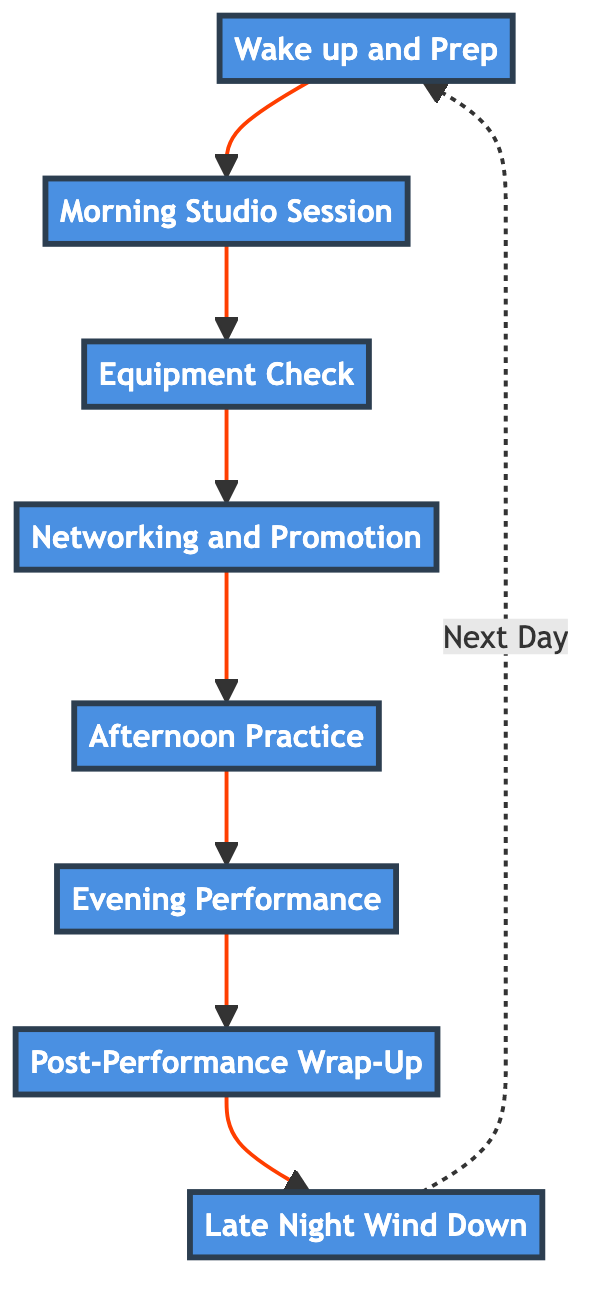What is the first task of the day? The diagram shows that the first task, represented by the first node, is "Wake up and Prep." This establishes the starting point of the flow.
Answer: Wake up and Prep How many tasks are listed in the diagram? By counting the nodes in the flow chart, we see there are eight distinct tasks outlined in the diagram.
Answer: 8 Which task follows "Networking and Promotion"? The diagram indicates a directed flow from the "Networking and Promotion" node to the "Afternoon Practice" node. This shows the sequence of tasks.
Answer: Afternoon Practice What is the last task of the day? In the flow chart, the last task is "Late Night Wind Down," which is shown as the final node in the sequence.
Answer: Late Night Wind Down What task involves performing live? Examining the diagram, "Evening Performance" specifically refers to the task of performing live at a venue, highlighting its importance in the day's workflow.
Answer: Evening Performance Which tasks are involved in the morning session? The tasks that make up the morning session include "Wake up and Prep" followed by "Morning Studio Session," indicating the beginning of the productive part of the day.
Answer: Wake up and Prep, Morning Studio Session How does the flow chart indicate a day-to-day routine? The flowchart demonstrates a cyclical routine, as seen by the dashed arrow returning from "Late Night Wind Down" to "Wake up and Prep," suggesting the continuity of the daily tasks.
Answer: Yes What is the purpose of the "Post-Performance Wrap-Up"? This node highlights reflecting on the performance, ensuring that the DJ assesses their work, which is pivotal for growth and improvement in their craft.
Answer: Analyze what worked well and what needs improvement 